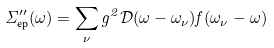Convert formula to latex. <formula><loc_0><loc_0><loc_500><loc_500>\Sigma ^ { \prime \prime } _ { \text {ep} } ( \omega ) = \sum _ { \nu } g ^ { 2 } \mathcal { D } ( \omega - \omega _ { \nu } ) f ( \omega _ { \nu } - \omega )</formula> 